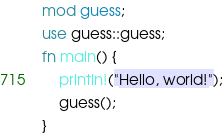<code> <loc_0><loc_0><loc_500><loc_500><_Rust_>mod guess;
use guess::guess;
fn main() {
    println!("Hello, world!");
    guess();
}
</code> 